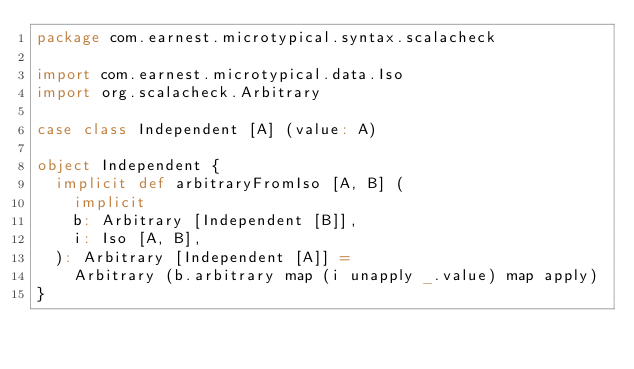Convert code to text. <code><loc_0><loc_0><loc_500><loc_500><_Scala_>package com.earnest.microtypical.syntax.scalacheck

import com.earnest.microtypical.data.Iso
import org.scalacheck.Arbitrary

case class Independent [A] (value: A)

object Independent {
  implicit def arbitraryFromIso [A, B] (
    implicit
    b: Arbitrary [Independent [B]],
    i: Iso [A, B],
  ): Arbitrary [Independent [A]] =
    Arbitrary (b.arbitrary map (i unapply _.value) map apply)
}
</code> 